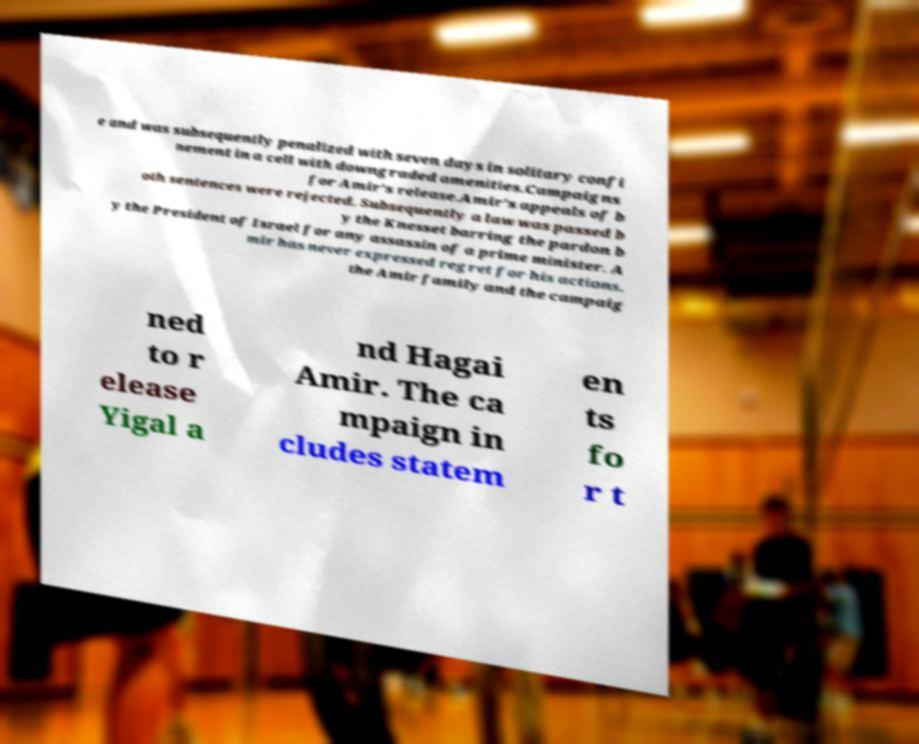What messages or text are displayed in this image? I need them in a readable, typed format. e and was subsequently penalized with seven days in solitary confi nement in a cell with downgraded amenities.Campaigns for Amir's release.Amir's appeals of b oth sentences were rejected. Subsequently a law was passed b y the Knesset barring the pardon b y the President of Israel for any assassin of a prime minister. A mir has never expressed regret for his actions. the Amir family and the campaig ned to r elease Yigal a nd Hagai Amir. The ca mpaign in cludes statem en ts fo r t 